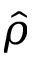Convert formula to latex. <formula><loc_0><loc_0><loc_500><loc_500>\hat { \rho }</formula> 